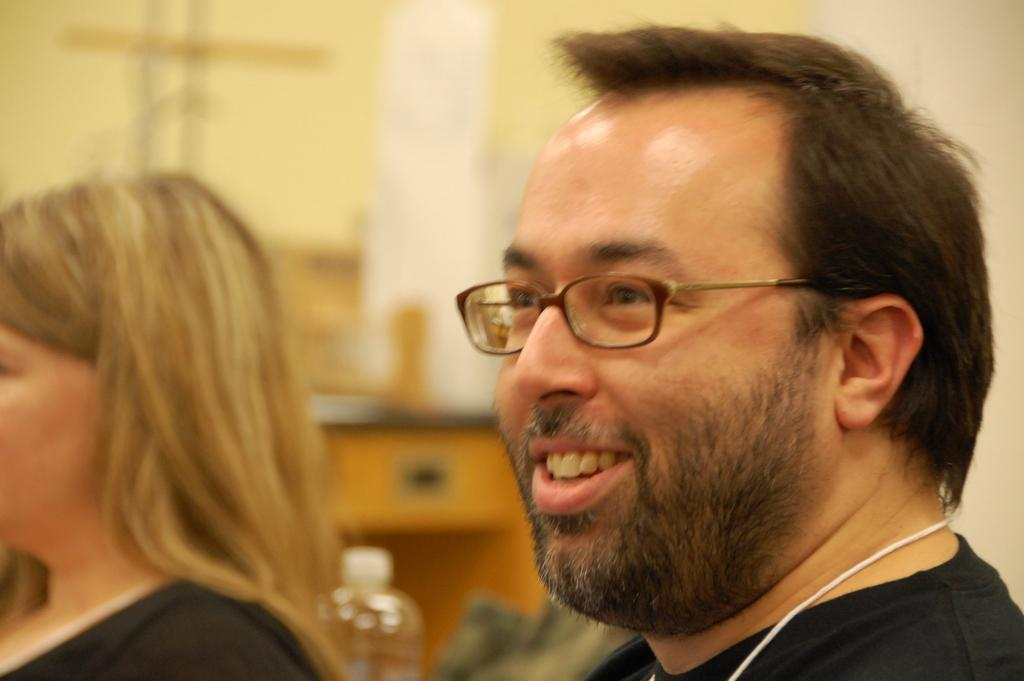How many people are in the image? There are two people in the image. What is unique about the appearance of one of the people? One of the people is wearing goggles. What else can be seen around the person wearing goggles? The person with goggles has a white-colored wire around their neck. What can be seen on a surface in the image? There is an object on a desk in the image. Can you describe the background of the image? The background of the image is blurred. What type of attack is being carried out by the bee in the image? There is no bee present in the image, so no attack can be observed. What topic are the two people discussing in the image? The image does not show a discussion between the two people, so it cannot be determined what they might be discussing. 